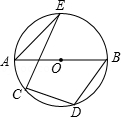Can you explore the implications of angle BDC being 110 degrees for other angles in the diagram? With angle BDC measured at 110 degrees, several relational insights emerge. Firstly, angle CBD also measures 110 degrees due to the properties of radii OB and OD creating an isosceles triangle BOD. Further, since angles at point D total 360 degrees, subtracting the sum of angles BDC and CBD (220 degrees total) from 360 gives angle DOC as 140 degrees. Angle DOC’s large measurement significantly impacts the distribution and nature of angles around the circle’s arch. 